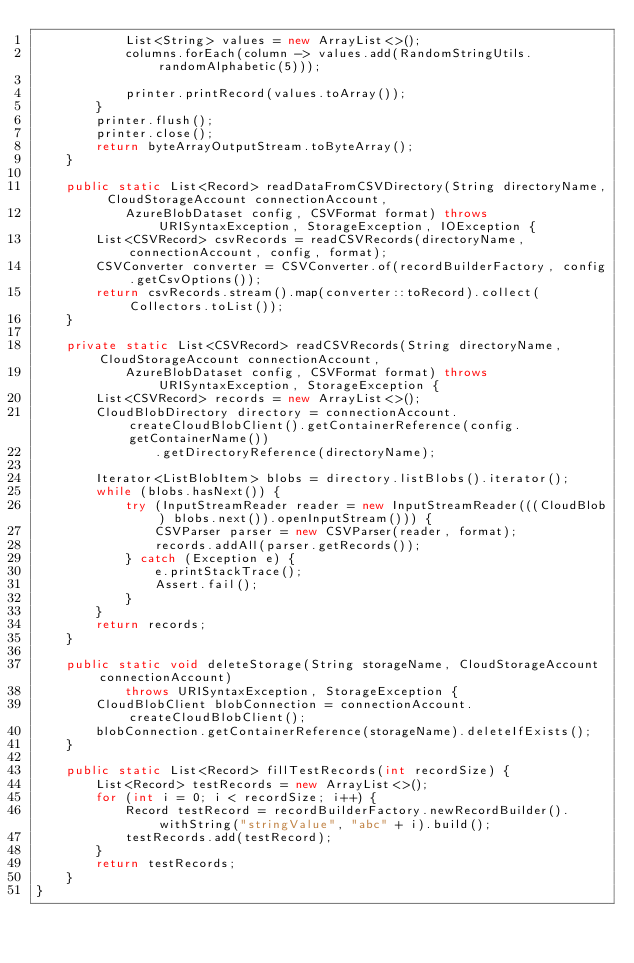Convert code to text. <code><loc_0><loc_0><loc_500><loc_500><_Java_>            List<String> values = new ArrayList<>();
            columns.forEach(column -> values.add(RandomStringUtils.randomAlphabetic(5)));

            printer.printRecord(values.toArray());
        }
        printer.flush();
        printer.close();
        return byteArrayOutputStream.toByteArray();
    }

    public static List<Record> readDataFromCSVDirectory(String directoryName, CloudStorageAccount connectionAccount,
            AzureBlobDataset config, CSVFormat format) throws URISyntaxException, StorageException, IOException {
        List<CSVRecord> csvRecords = readCSVRecords(directoryName, connectionAccount, config, format);
        CSVConverter converter = CSVConverter.of(recordBuilderFactory, config.getCsvOptions());
        return csvRecords.stream().map(converter::toRecord).collect(Collectors.toList());
    }

    private static List<CSVRecord> readCSVRecords(String directoryName, CloudStorageAccount connectionAccount,
            AzureBlobDataset config, CSVFormat format) throws URISyntaxException, StorageException {
        List<CSVRecord> records = new ArrayList<>();
        CloudBlobDirectory directory = connectionAccount.createCloudBlobClient().getContainerReference(config.getContainerName())
                .getDirectoryReference(directoryName);

        Iterator<ListBlobItem> blobs = directory.listBlobs().iterator();
        while (blobs.hasNext()) {
            try (InputStreamReader reader = new InputStreamReader(((CloudBlob) blobs.next()).openInputStream())) {
                CSVParser parser = new CSVParser(reader, format);
                records.addAll(parser.getRecords());
            } catch (Exception e) {
                e.printStackTrace();
                Assert.fail();
            }
        }
        return records;
    }

    public static void deleteStorage(String storageName, CloudStorageAccount connectionAccount)
            throws URISyntaxException, StorageException {
        CloudBlobClient blobConnection = connectionAccount.createCloudBlobClient();
        blobConnection.getContainerReference(storageName).deleteIfExists();
    }

    public static List<Record> fillTestRecords(int recordSize) {
        List<Record> testRecords = new ArrayList<>();
        for (int i = 0; i < recordSize; i++) {
            Record testRecord = recordBuilderFactory.newRecordBuilder().withString("stringValue", "abc" + i).build();
            testRecords.add(testRecord);
        }
        return testRecords;
    }
}
</code> 